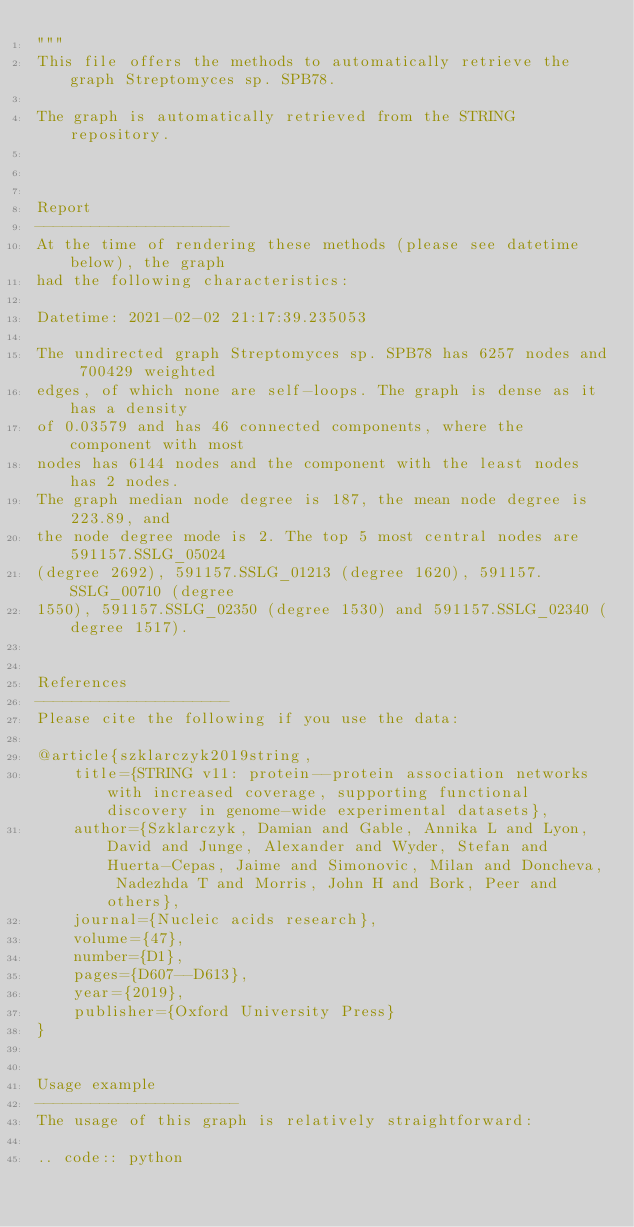Convert code to text. <code><loc_0><loc_0><loc_500><loc_500><_Python_>"""
This file offers the methods to automatically retrieve the graph Streptomyces sp. SPB78.

The graph is automatically retrieved from the STRING repository. 



Report
---------------------
At the time of rendering these methods (please see datetime below), the graph
had the following characteristics:

Datetime: 2021-02-02 21:17:39.235053

The undirected graph Streptomyces sp. SPB78 has 6257 nodes and 700429 weighted
edges, of which none are self-loops. The graph is dense as it has a density
of 0.03579 and has 46 connected components, where the component with most
nodes has 6144 nodes and the component with the least nodes has 2 nodes.
The graph median node degree is 187, the mean node degree is 223.89, and
the node degree mode is 2. The top 5 most central nodes are 591157.SSLG_05024
(degree 2692), 591157.SSLG_01213 (degree 1620), 591157.SSLG_00710 (degree
1550), 591157.SSLG_02350 (degree 1530) and 591157.SSLG_02340 (degree 1517).


References
---------------------
Please cite the following if you use the data:

@article{szklarczyk2019string,
    title={STRING v11: protein--protein association networks with increased coverage, supporting functional discovery in genome-wide experimental datasets},
    author={Szklarczyk, Damian and Gable, Annika L and Lyon, David and Junge, Alexander and Wyder, Stefan and Huerta-Cepas, Jaime and Simonovic, Milan and Doncheva, Nadezhda T and Morris, John H and Bork, Peer and others},
    journal={Nucleic acids research},
    volume={47},
    number={D1},
    pages={D607--D613},
    year={2019},
    publisher={Oxford University Press}
}


Usage example
----------------------
The usage of this graph is relatively straightforward:

.. code:: python
</code> 